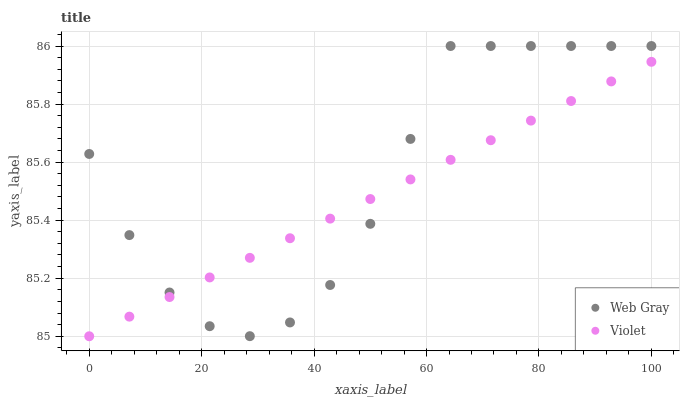Does Violet have the minimum area under the curve?
Answer yes or no. Yes. Does Web Gray have the maximum area under the curve?
Answer yes or no. Yes. Does Violet have the maximum area under the curve?
Answer yes or no. No. Is Violet the smoothest?
Answer yes or no. Yes. Is Web Gray the roughest?
Answer yes or no. Yes. Is Violet the roughest?
Answer yes or no. No. Does Violet have the lowest value?
Answer yes or no. Yes. Does Web Gray have the highest value?
Answer yes or no. Yes. Does Violet have the highest value?
Answer yes or no. No. Does Web Gray intersect Violet?
Answer yes or no. Yes. Is Web Gray less than Violet?
Answer yes or no. No. Is Web Gray greater than Violet?
Answer yes or no. No. 